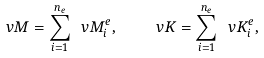Convert formula to latex. <formula><loc_0><loc_0><loc_500><loc_500>\ v M = \sum _ { i = 1 } ^ { n _ { e } } \ v M _ { i } ^ { e } , \quad \ v K = \sum _ { i = 1 } ^ { n _ { e } } \ v K ^ { e } _ { i } ,</formula> 